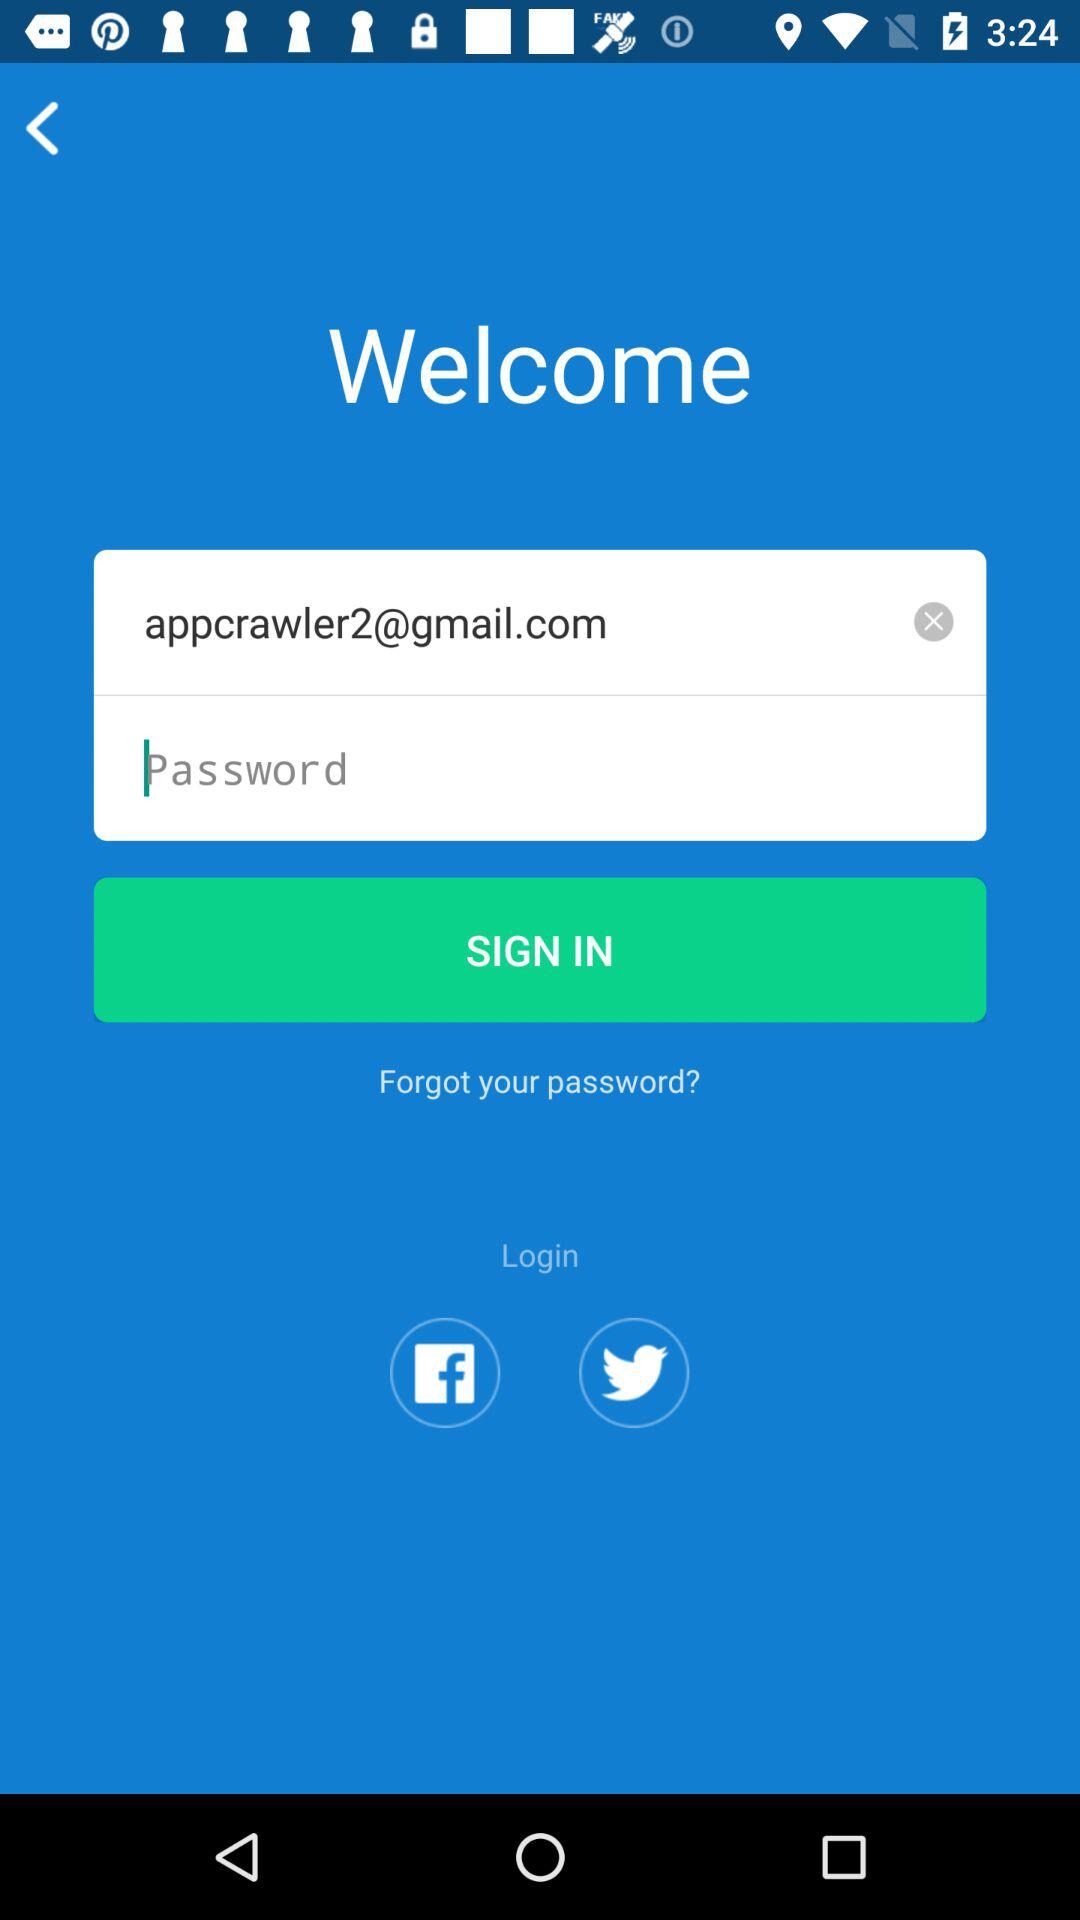What accounts can be used to log in? The accounts that can be used to log in are "Facebook" and "Twitter". 